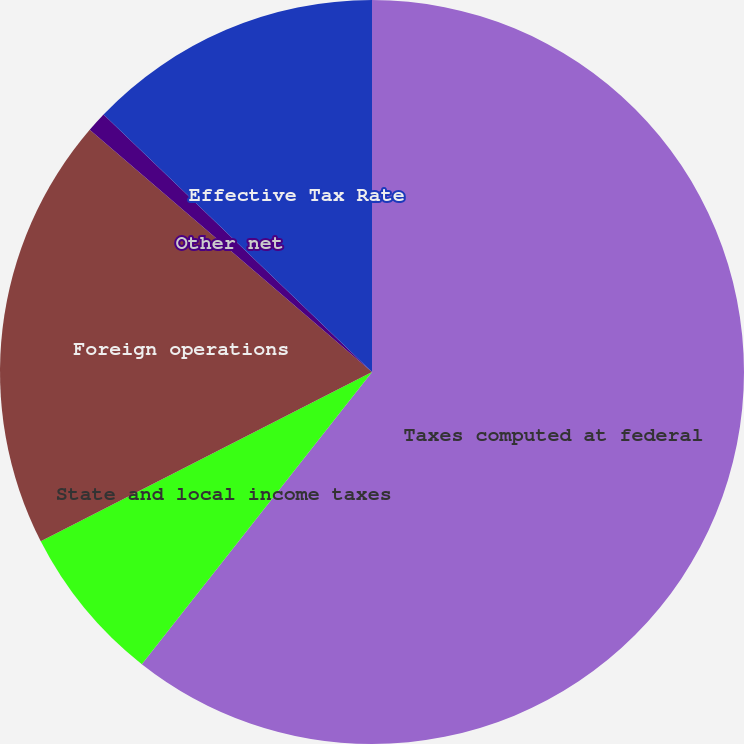<chart> <loc_0><loc_0><loc_500><loc_500><pie_chart><fcel>Taxes computed at federal<fcel>State and local income taxes<fcel>Foreign operations<fcel>Other net<fcel>Effective Tax Rate<nl><fcel>60.62%<fcel>6.86%<fcel>18.81%<fcel>0.88%<fcel>12.83%<nl></chart> 